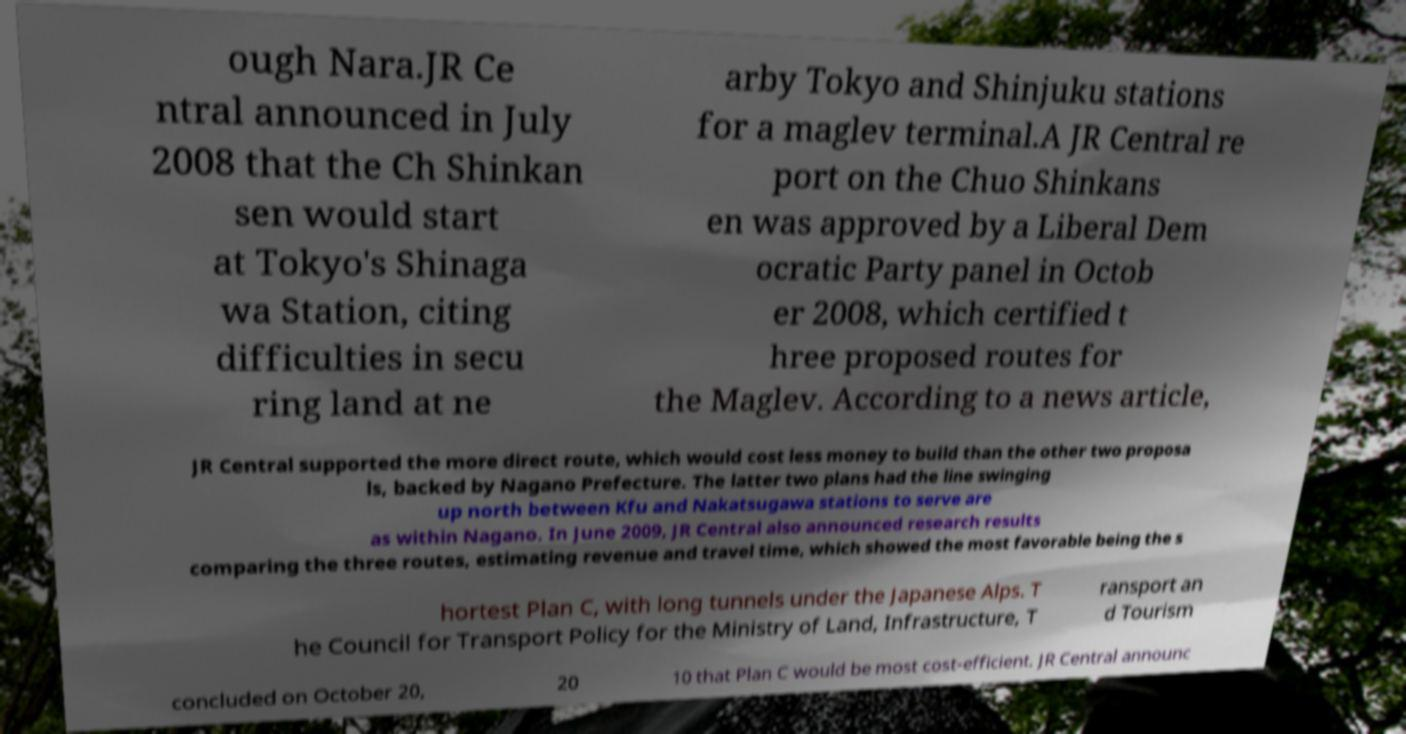Can you read and provide the text displayed in the image?This photo seems to have some interesting text. Can you extract and type it out for me? ough Nara.JR Ce ntral announced in July 2008 that the Ch Shinkan sen would start at Tokyo's Shinaga wa Station, citing difficulties in secu ring land at ne arby Tokyo and Shinjuku stations for a maglev terminal.A JR Central re port on the Chuo Shinkans en was approved by a Liberal Dem ocratic Party panel in Octob er 2008, which certified t hree proposed routes for the Maglev. According to a news article, JR Central supported the more direct route, which would cost less money to build than the other two proposa ls, backed by Nagano Prefecture. The latter two plans had the line swinging up north between Kfu and Nakatsugawa stations to serve are as within Nagano. In June 2009, JR Central also announced research results comparing the three routes, estimating revenue and travel time, which showed the most favorable being the s hortest Plan C, with long tunnels under the Japanese Alps. T he Council for Transport Policy for the Ministry of Land, Infrastructure, T ransport an d Tourism concluded on October 20, 20 10 that Plan C would be most cost-efficient. JR Central announc 